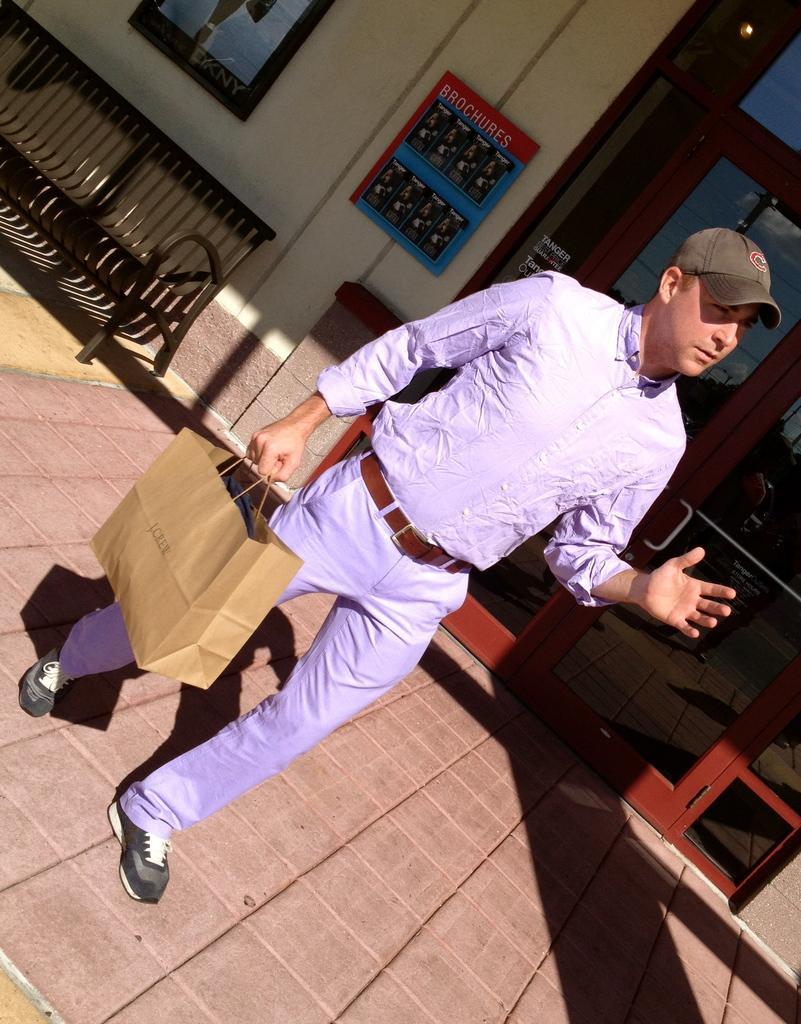Could you give a brief overview of what you see in this image? This is the picture of a building. In the foreground there is a person holding the bag and he is walking. At the back there is a sofa and there is a frame on the wall and there is a door. At the bottom there are tiles. 